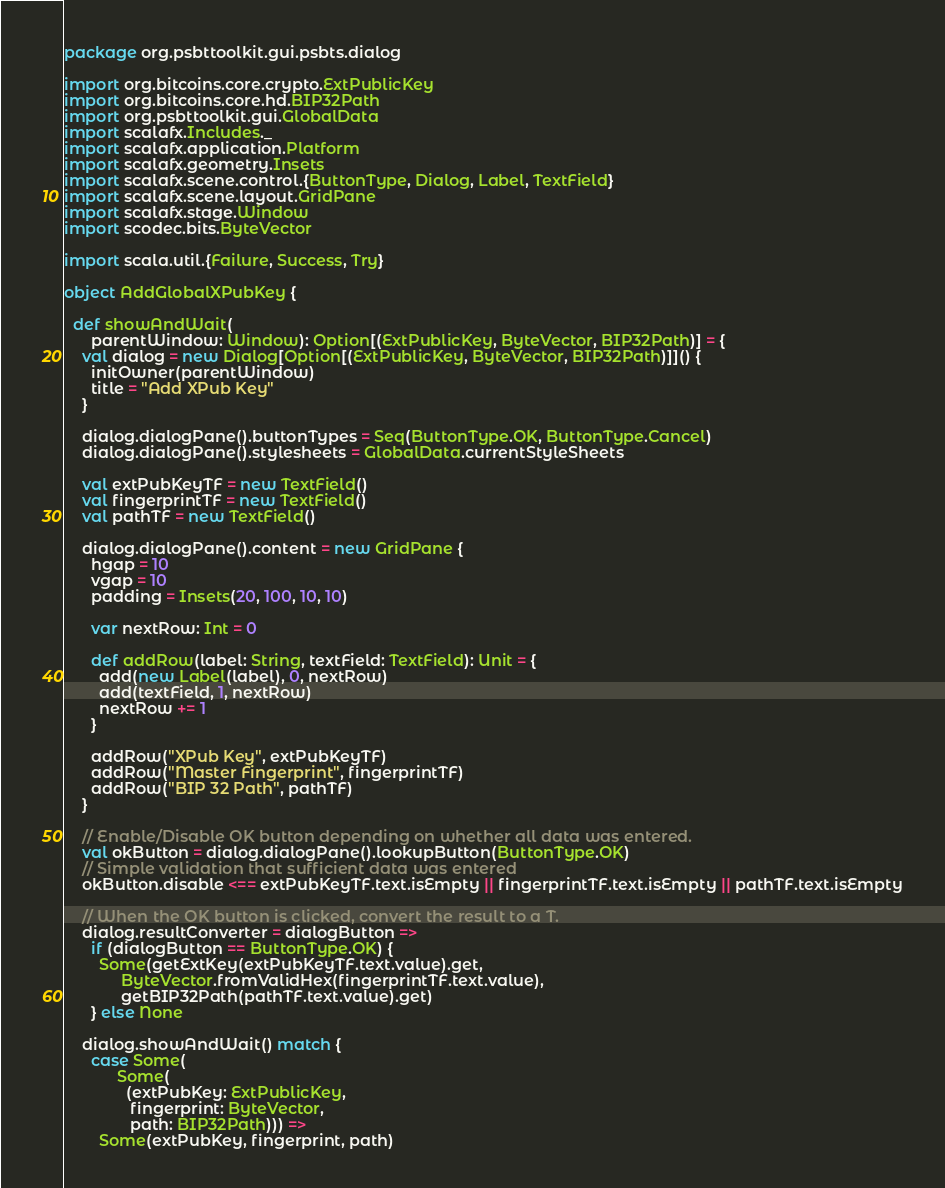Convert code to text. <code><loc_0><loc_0><loc_500><loc_500><_Scala_>package org.psbttoolkit.gui.psbts.dialog

import org.bitcoins.core.crypto.ExtPublicKey
import org.bitcoins.core.hd.BIP32Path
import org.psbttoolkit.gui.GlobalData
import scalafx.Includes._
import scalafx.application.Platform
import scalafx.geometry.Insets
import scalafx.scene.control.{ButtonType, Dialog, Label, TextField}
import scalafx.scene.layout.GridPane
import scalafx.stage.Window
import scodec.bits.ByteVector

import scala.util.{Failure, Success, Try}

object AddGlobalXPubKey {

  def showAndWait(
      parentWindow: Window): Option[(ExtPublicKey, ByteVector, BIP32Path)] = {
    val dialog = new Dialog[Option[(ExtPublicKey, ByteVector, BIP32Path)]]() {
      initOwner(parentWindow)
      title = "Add XPub Key"
    }

    dialog.dialogPane().buttonTypes = Seq(ButtonType.OK, ButtonType.Cancel)
    dialog.dialogPane().stylesheets = GlobalData.currentStyleSheets

    val extPubKeyTF = new TextField()
    val fingerprintTF = new TextField()
    val pathTF = new TextField()

    dialog.dialogPane().content = new GridPane {
      hgap = 10
      vgap = 10
      padding = Insets(20, 100, 10, 10)

      var nextRow: Int = 0

      def addRow(label: String, textField: TextField): Unit = {
        add(new Label(label), 0, nextRow)
        add(textField, 1, nextRow)
        nextRow += 1
      }

      addRow("XPub Key", extPubKeyTF)
      addRow("Master Fingerprint", fingerprintTF)
      addRow("BIP 32 Path", pathTF)
    }

    // Enable/Disable OK button depending on whether all data was entered.
    val okButton = dialog.dialogPane().lookupButton(ButtonType.OK)
    // Simple validation that sufficient data was entered
    okButton.disable <== extPubKeyTF.text.isEmpty || fingerprintTF.text.isEmpty || pathTF.text.isEmpty

    // When the OK button is clicked, convert the result to a T.
    dialog.resultConverter = dialogButton =>
      if (dialogButton == ButtonType.OK) {
        Some(getExtKey(extPubKeyTF.text.value).get,
             ByteVector.fromValidHex(fingerprintTF.text.value),
             getBIP32Path(pathTF.text.value).get)
      } else None

    dialog.showAndWait() match {
      case Some(
            Some(
              (extPubKey: ExtPublicKey,
               fingerprint: ByteVector,
               path: BIP32Path))) =>
        Some(extPubKey, fingerprint, path)</code> 